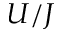Convert formula to latex. <formula><loc_0><loc_0><loc_500><loc_500>U / J</formula> 